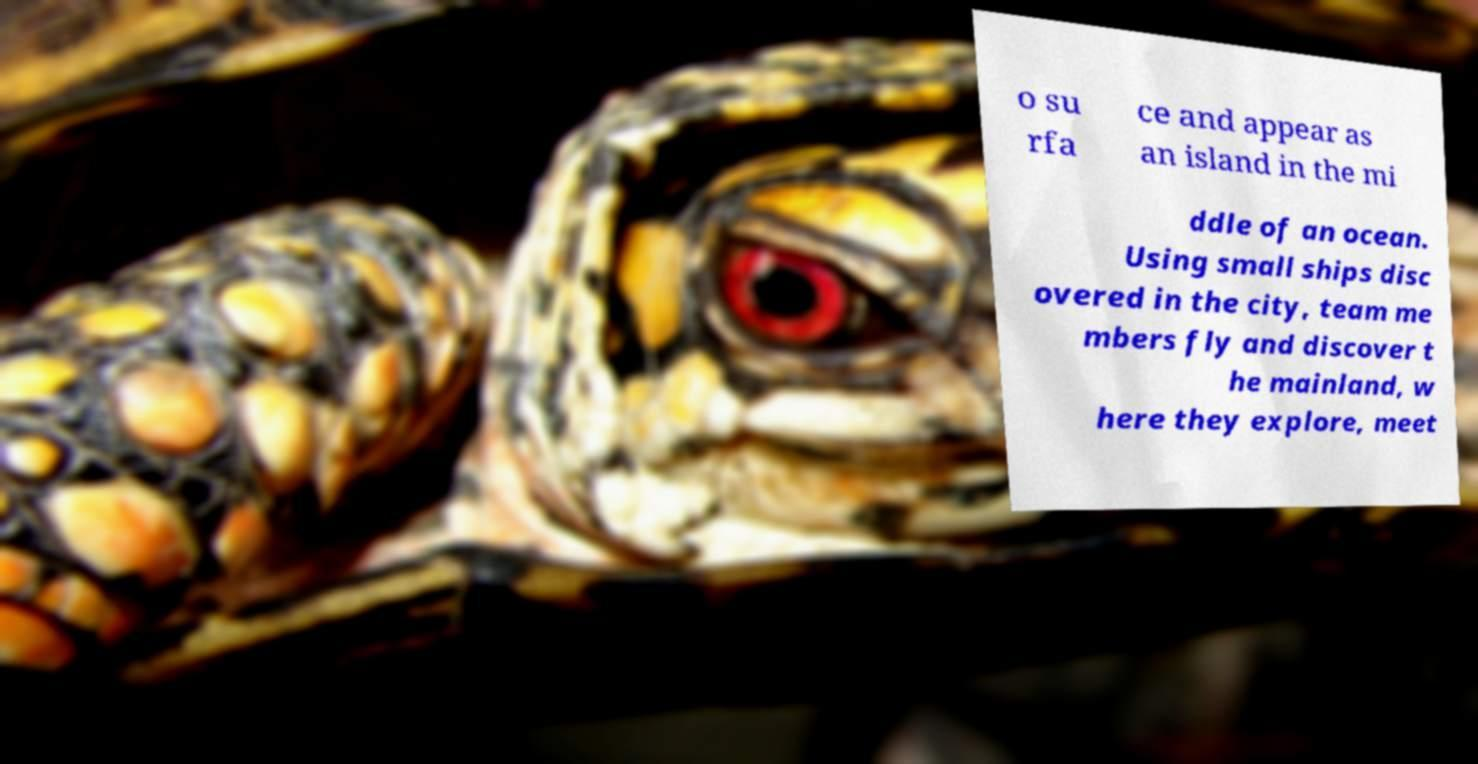Can you accurately transcribe the text from the provided image for me? o su rfa ce and appear as an island in the mi ddle of an ocean. Using small ships disc overed in the city, team me mbers fly and discover t he mainland, w here they explore, meet 